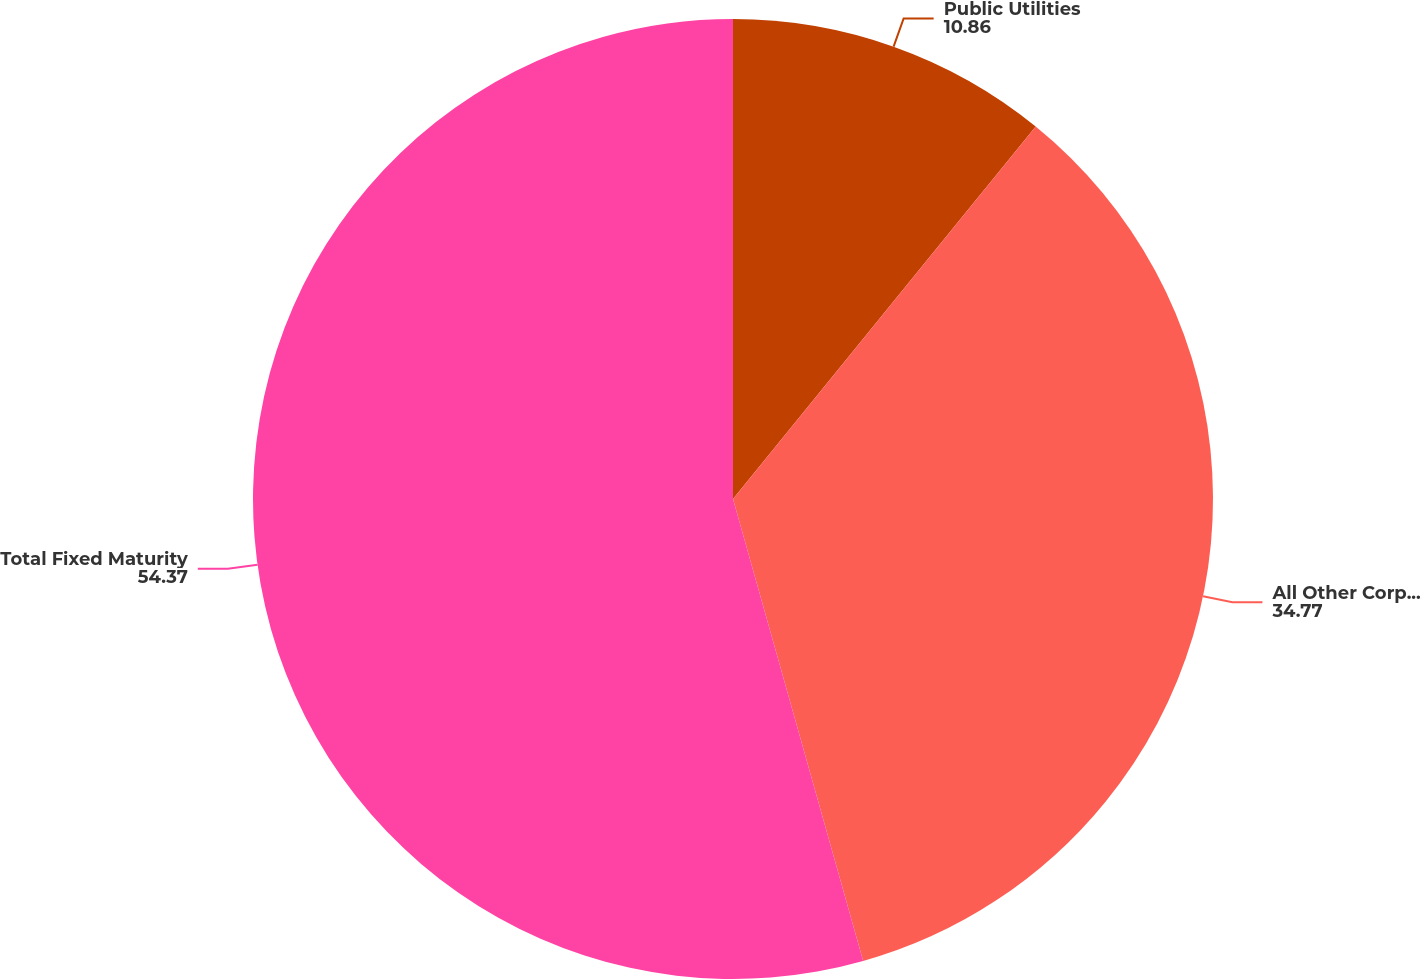Convert chart. <chart><loc_0><loc_0><loc_500><loc_500><pie_chart><fcel>Public Utilities<fcel>All Other Corporate Bonds<fcel>Total Fixed Maturity<nl><fcel>10.86%<fcel>34.77%<fcel>54.37%<nl></chart> 